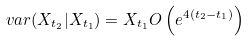<formula> <loc_0><loc_0><loc_500><loc_500>\ v a r ( X _ { t _ { 2 } } | X _ { t _ { 1 } } ) = X _ { t _ { 1 } } O \left ( e ^ { 4 ( t _ { 2 } - t _ { 1 } ) } \right )</formula> 